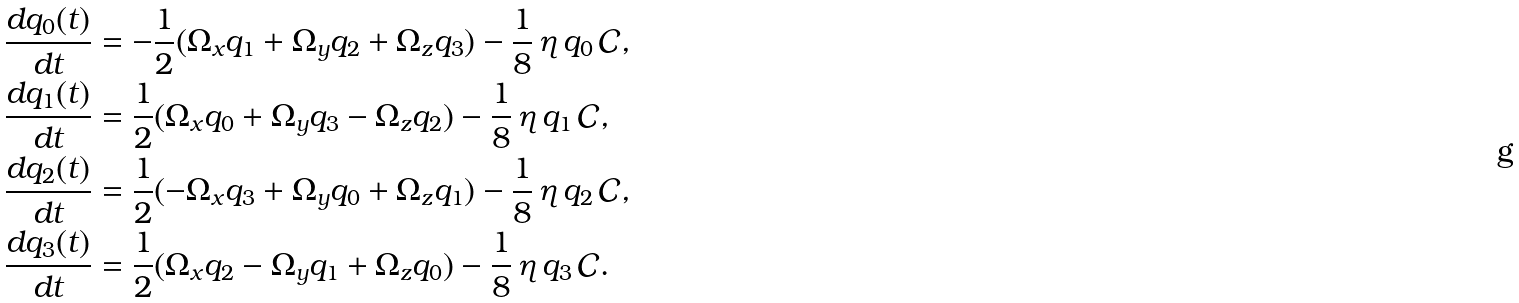Convert formula to latex. <formula><loc_0><loc_0><loc_500><loc_500>\frac { d q _ { 0 } ( t ) } { d t } & = - \frac { 1 } { 2 } ( \Omega _ { x } q _ { 1 } + \Omega _ { y } q _ { 2 } + \Omega _ { z } q _ { 3 } ) - \frac { 1 } { 8 } \, \eta \, q _ { 0 } \, \mathcal { C } , \\ \frac { d q _ { 1 } ( t ) } { d t } & = \frac { 1 } { 2 } ( \Omega _ { x } q _ { 0 } + \Omega _ { y } q _ { 3 } - \Omega _ { z } q _ { 2 } ) - \frac { 1 } { 8 } \, \eta \, q _ { 1 } \, \mathcal { C } , \\ \frac { d q _ { 2 } ( t ) } { d t } & = \frac { 1 } { 2 } ( - \Omega _ { x } q _ { 3 } + \Omega _ { y } q _ { 0 } + \Omega _ { z } q _ { 1 } ) - \frac { 1 } { 8 } \, \eta \, q _ { 2 } \, \mathcal { C } , \\ \frac { d q _ { 3 } ( t ) } { d t } & = \frac { 1 } { 2 } ( \Omega _ { x } q _ { 2 } - \Omega _ { y } q _ { 1 } + \Omega _ { z } q _ { 0 } ) - \frac { 1 } { 8 } \, \eta \, q _ { 3 } \, \mathcal { C } .</formula> 